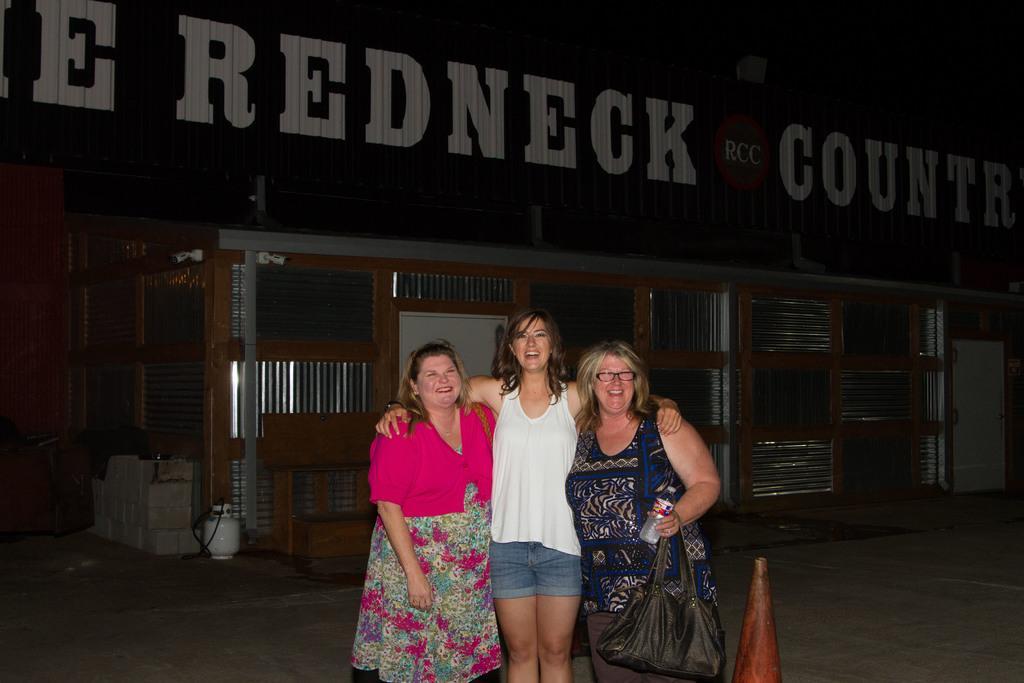Could you give a brief overview of what you see in this image? There are three people. The three people are standing. They give a smile. On the right side we have a woman. She is wearing a bottle and bag. We can see in the background there is a shed and road. 